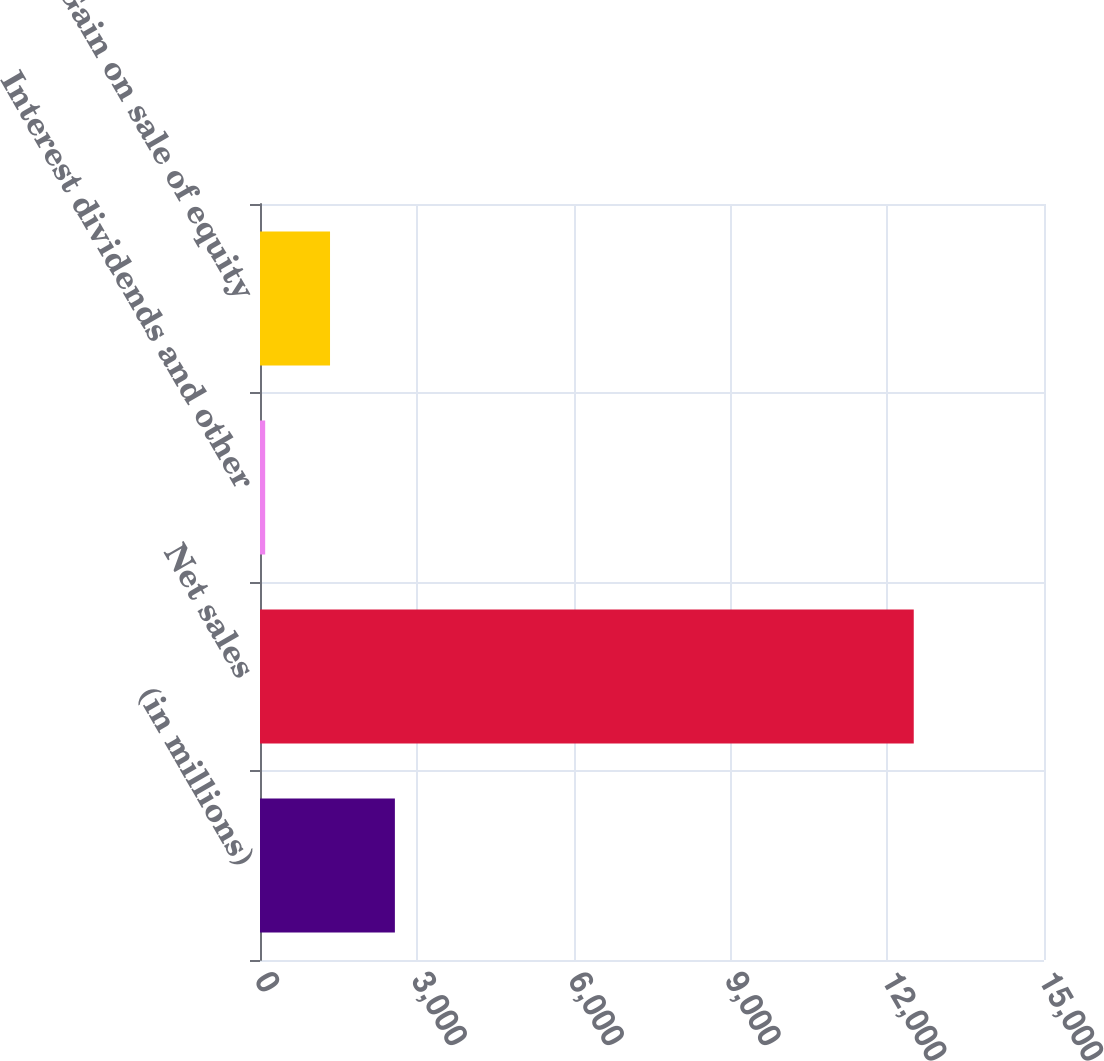<chart> <loc_0><loc_0><loc_500><loc_500><bar_chart><fcel>(in millions)<fcel>Net sales<fcel>Interest dividends and other<fcel>Gain on sale of equity<nl><fcel>2580.8<fcel>12508<fcel>99<fcel>1339.9<nl></chart> 